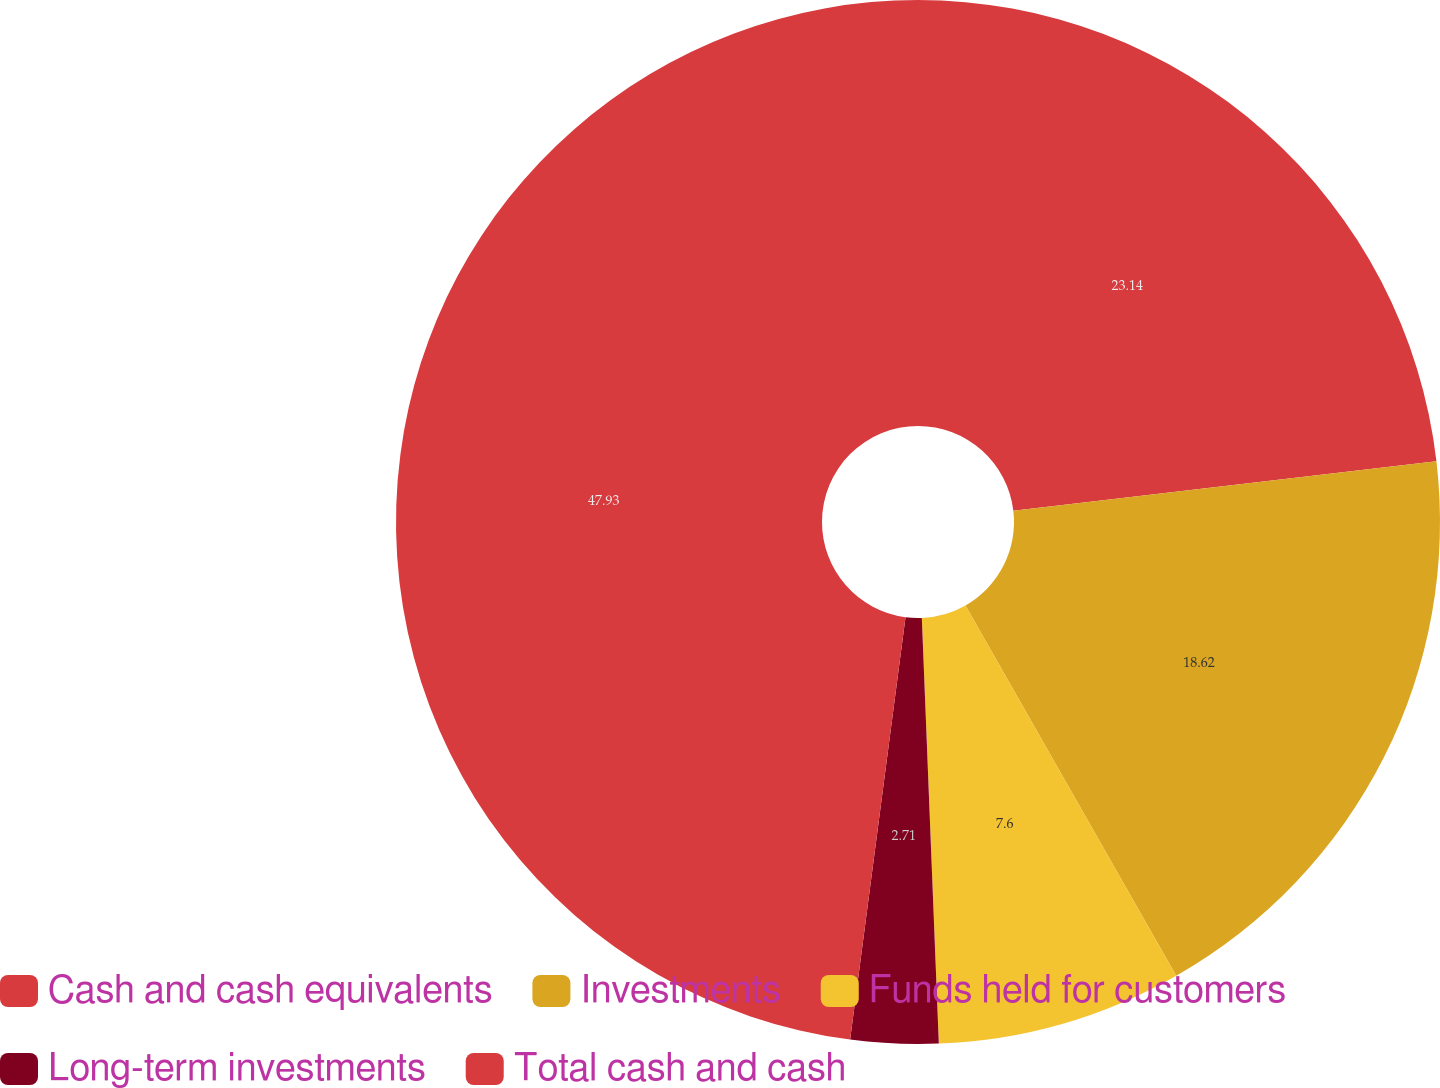Convert chart to OTSL. <chart><loc_0><loc_0><loc_500><loc_500><pie_chart><fcel>Cash and cash equivalents<fcel>Investments<fcel>Funds held for customers<fcel>Long-term investments<fcel>Total cash and cash<nl><fcel>23.14%<fcel>18.62%<fcel>7.6%<fcel>2.71%<fcel>47.92%<nl></chart> 